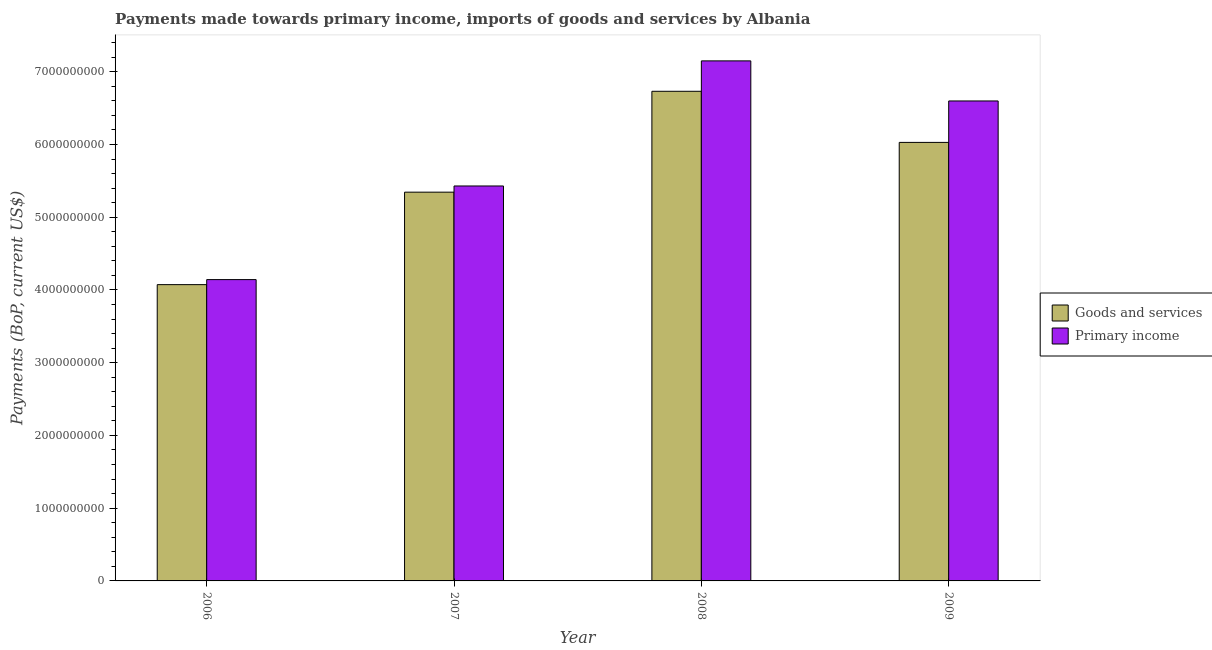How many different coloured bars are there?
Offer a very short reply. 2. How many groups of bars are there?
Offer a terse response. 4. Are the number of bars on each tick of the X-axis equal?
Keep it short and to the point. Yes. What is the label of the 2nd group of bars from the left?
Your answer should be compact. 2007. In how many cases, is the number of bars for a given year not equal to the number of legend labels?
Keep it short and to the point. 0. What is the payments made towards primary income in 2008?
Your response must be concise. 7.15e+09. Across all years, what is the maximum payments made towards goods and services?
Your answer should be compact. 6.73e+09. Across all years, what is the minimum payments made towards primary income?
Offer a very short reply. 4.14e+09. In which year was the payments made towards primary income maximum?
Offer a terse response. 2008. What is the total payments made towards primary income in the graph?
Your response must be concise. 2.33e+1. What is the difference between the payments made towards primary income in 2006 and that in 2008?
Offer a terse response. -3.01e+09. What is the difference between the payments made towards goods and services in 2008 and the payments made towards primary income in 2006?
Keep it short and to the point. 2.66e+09. What is the average payments made towards primary income per year?
Keep it short and to the point. 5.83e+09. In how many years, is the payments made towards primary income greater than 5600000000 US$?
Your answer should be compact. 2. What is the ratio of the payments made towards primary income in 2007 to that in 2008?
Your response must be concise. 0.76. What is the difference between the highest and the second highest payments made towards goods and services?
Your response must be concise. 7.02e+08. What is the difference between the highest and the lowest payments made towards goods and services?
Ensure brevity in your answer.  2.66e+09. In how many years, is the payments made towards goods and services greater than the average payments made towards goods and services taken over all years?
Offer a very short reply. 2. Is the sum of the payments made towards goods and services in 2006 and 2008 greater than the maximum payments made towards primary income across all years?
Provide a succinct answer. Yes. What does the 1st bar from the left in 2006 represents?
Give a very brief answer. Goods and services. What does the 1st bar from the right in 2009 represents?
Ensure brevity in your answer.  Primary income. How many bars are there?
Keep it short and to the point. 8. Are all the bars in the graph horizontal?
Ensure brevity in your answer.  No. Are the values on the major ticks of Y-axis written in scientific E-notation?
Provide a short and direct response. No. Does the graph contain any zero values?
Offer a terse response. No. Does the graph contain grids?
Offer a very short reply. No. Where does the legend appear in the graph?
Give a very brief answer. Center right. How many legend labels are there?
Give a very brief answer. 2. How are the legend labels stacked?
Give a very brief answer. Vertical. What is the title of the graph?
Give a very brief answer. Payments made towards primary income, imports of goods and services by Albania. Does "Excluding technical cooperation" appear as one of the legend labels in the graph?
Provide a succinct answer. No. What is the label or title of the X-axis?
Offer a terse response. Year. What is the label or title of the Y-axis?
Make the answer very short. Payments (BoP, current US$). What is the Payments (BoP, current US$) in Goods and services in 2006?
Offer a very short reply. 4.07e+09. What is the Payments (BoP, current US$) of Primary income in 2006?
Provide a succinct answer. 4.14e+09. What is the Payments (BoP, current US$) in Goods and services in 2007?
Offer a terse response. 5.34e+09. What is the Payments (BoP, current US$) in Primary income in 2007?
Your answer should be compact. 5.43e+09. What is the Payments (BoP, current US$) in Goods and services in 2008?
Your answer should be compact. 6.73e+09. What is the Payments (BoP, current US$) of Primary income in 2008?
Your answer should be very brief. 7.15e+09. What is the Payments (BoP, current US$) in Goods and services in 2009?
Your answer should be very brief. 6.03e+09. What is the Payments (BoP, current US$) in Primary income in 2009?
Keep it short and to the point. 6.60e+09. Across all years, what is the maximum Payments (BoP, current US$) of Goods and services?
Your response must be concise. 6.73e+09. Across all years, what is the maximum Payments (BoP, current US$) in Primary income?
Offer a very short reply. 7.15e+09. Across all years, what is the minimum Payments (BoP, current US$) in Goods and services?
Your answer should be very brief. 4.07e+09. Across all years, what is the minimum Payments (BoP, current US$) in Primary income?
Offer a very short reply. 4.14e+09. What is the total Payments (BoP, current US$) in Goods and services in the graph?
Keep it short and to the point. 2.22e+1. What is the total Payments (BoP, current US$) in Primary income in the graph?
Offer a terse response. 2.33e+1. What is the difference between the Payments (BoP, current US$) in Goods and services in 2006 and that in 2007?
Make the answer very short. -1.27e+09. What is the difference between the Payments (BoP, current US$) in Primary income in 2006 and that in 2007?
Your answer should be compact. -1.29e+09. What is the difference between the Payments (BoP, current US$) of Goods and services in 2006 and that in 2008?
Offer a terse response. -2.66e+09. What is the difference between the Payments (BoP, current US$) of Primary income in 2006 and that in 2008?
Keep it short and to the point. -3.01e+09. What is the difference between the Payments (BoP, current US$) of Goods and services in 2006 and that in 2009?
Your response must be concise. -1.96e+09. What is the difference between the Payments (BoP, current US$) in Primary income in 2006 and that in 2009?
Offer a terse response. -2.46e+09. What is the difference between the Payments (BoP, current US$) in Goods and services in 2007 and that in 2008?
Offer a terse response. -1.39e+09. What is the difference between the Payments (BoP, current US$) in Primary income in 2007 and that in 2008?
Keep it short and to the point. -1.72e+09. What is the difference between the Payments (BoP, current US$) of Goods and services in 2007 and that in 2009?
Keep it short and to the point. -6.84e+08. What is the difference between the Payments (BoP, current US$) of Primary income in 2007 and that in 2009?
Your answer should be compact. -1.17e+09. What is the difference between the Payments (BoP, current US$) of Goods and services in 2008 and that in 2009?
Your answer should be very brief. 7.02e+08. What is the difference between the Payments (BoP, current US$) of Primary income in 2008 and that in 2009?
Give a very brief answer. 5.51e+08. What is the difference between the Payments (BoP, current US$) in Goods and services in 2006 and the Payments (BoP, current US$) in Primary income in 2007?
Provide a short and direct response. -1.36e+09. What is the difference between the Payments (BoP, current US$) in Goods and services in 2006 and the Payments (BoP, current US$) in Primary income in 2008?
Provide a short and direct response. -3.08e+09. What is the difference between the Payments (BoP, current US$) of Goods and services in 2006 and the Payments (BoP, current US$) of Primary income in 2009?
Make the answer very short. -2.52e+09. What is the difference between the Payments (BoP, current US$) in Goods and services in 2007 and the Payments (BoP, current US$) in Primary income in 2008?
Offer a very short reply. -1.80e+09. What is the difference between the Payments (BoP, current US$) in Goods and services in 2007 and the Payments (BoP, current US$) in Primary income in 2009?
Keep it short and to the point. -1.25e+09. What is the difference between the Payments (BoP, current US$) in Goods and services in 2008 and the Payments (BoP, current US$) in Primary income in 2009?
Offer a terse response. 1.33e+08. What is the average Payments (BoP, current US$) in Goods and services per year?
Keep it short and to the point. 5.54e+09. What is the average Payments (BoP, current US$) of Primary income per year?
Offer a very short reply. 5.83e+09. In the year 2006, what is the difference between the Payments (BoP, current US$) in Goods and services and Payments (BoP, current US$) in Primary income?
Offer a very short reply. -6.91e+07. In the year 2007, what is the difference between the Payments (BoP, current US$) in Goods and services and Payments (BoP, current US$) in Primary income?
Ensure brevity in your answer.  -8.51e+07. In the year 2008, what is the difference between the Payments (BoP, current US$) of Goods and services and Payments (BoP, current US$) of Primary income?
Give a very brief answer. -4.18e+08. In the year 2009, what is the difference between the Payments (BoP, current US$) of Goods and services and Payments (BoP, current US$) of Primary income?
Your answer should be compact. -5.70e+08. What is the ratio of the Payments (BoP, current US$) of Goods and services in 2006 to that in 2007?
Provide a short and direct response. 0.76. What is the ratio of the Payments (BoP, current US$) in Primary income in 2006 to that in 2007?
Make the answer very short. 0.76. What is the ratio of the Payments (BoP, current US$) in Goods and services in 2006 to that in 2008?
Give a very brief answer. 0.61. What is the ratio of the Payments (BoP, current US$) of Primary income in 2006 to that in 2008?
Provide a succinct answer. 0.58. What is the ratio of the Payments (BoP, current US$) of Goods and services in 2006 to that in 2009?
Give a very brief answer. 0.68. What is the ratio of the Payments (BoP, current US$) of Primary income in 2006 to that in 2009?
Your response must be concise. 0.63. What is the ratio of the Payments (BoP, current US$) of Goods and services in 2007 to that in 2008?
Your answer should be compact. 0.79. What is the ratio of the Payments (BoP, current US$) of Primary income in 2007 to that in 2008?
Offer a terse response. 0.76. What is the ratio of the Payments (BoP, current US$) of Goods and services in 2007 to that in 2009?
Keep it short and to the point. 0.89. What is the ratio of the Payments (BoP, current US$) of Primary income in 2007 to that in 2009?
Keep it short and to the point. 0.82. What is the ratio of the Payments (BoP, current US$) of Goods and services in 2008 to that in 2009?
Your answer should be very brief. 1.12. What is the ratio of the Payments (BoP, current US$) in Primary income in 2008 to that in 2009?
Offer a very short reply. 1.08. What is the difference between the highest and the second highest Payments (BoP, current US$) in Goods and services?
Make the answer very short. 7.02e+08. What is the difference between the highest and the second highest Payments (BoP, current US$) in Primary income?
Make the answer very short. 5.51e+08. What is the difference between the highest and the lowest Payments (BoP, current US$) in Goods and services?
Make the answer very short. 2.66e+09. What is the difference between the highest and the lowest Payments (BoP, current US$) in Primary income?
Offer a terse response. 3.01e+09. 